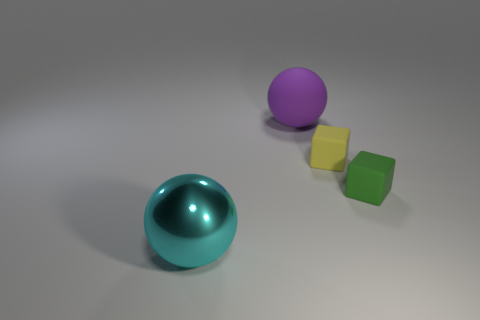Subtract 1 cubes. How many cubes are left? 1 Subtract all green cubes. How many cubes are left? 1 Add 4 tiny red metal balls. How many objects exist? 8 Subtract 0 brown cubes. How many objects are left? 4 Subtract all gray spheres. Subtract all blue cubes. How many spheres are left? 2 Subtract all cyan spheres. How many green blocks are left? 1 Subtract all rubber blocks. Subtract all tiny matte objects. How many objects are left? 0 Add 3 yellow rubber objects. How many yellow rubber objects are left? 4 Add 3 small blue blocks. How many small blue blocks exist? 3 